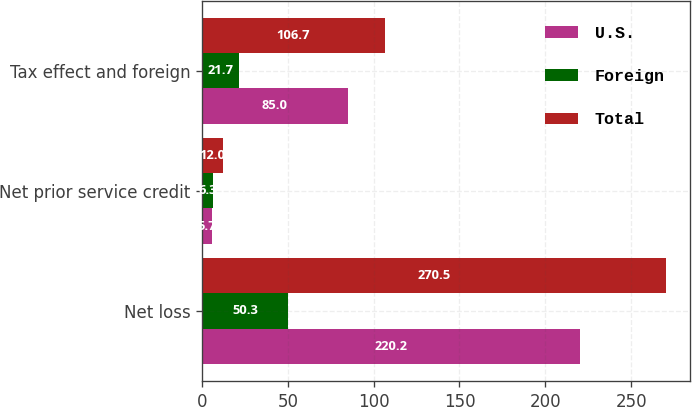<chart> <loc_0><loc_0><loc_500><loc_500><stacked_bar_chart><ecel><fcel>Net loss<fcel>Net prior service credit<fcel>Tax effect and foreign<nl><fcel>U.S.<fcel>220.2<fcel>5.7<fcel>85<nl><fcel>Foreign<fcel>50.3<fcel>6.3<fcel>21.7<nl><fcel>Total<fcel>270.5<fcel>12<fcel>106.7<nl></chart> 